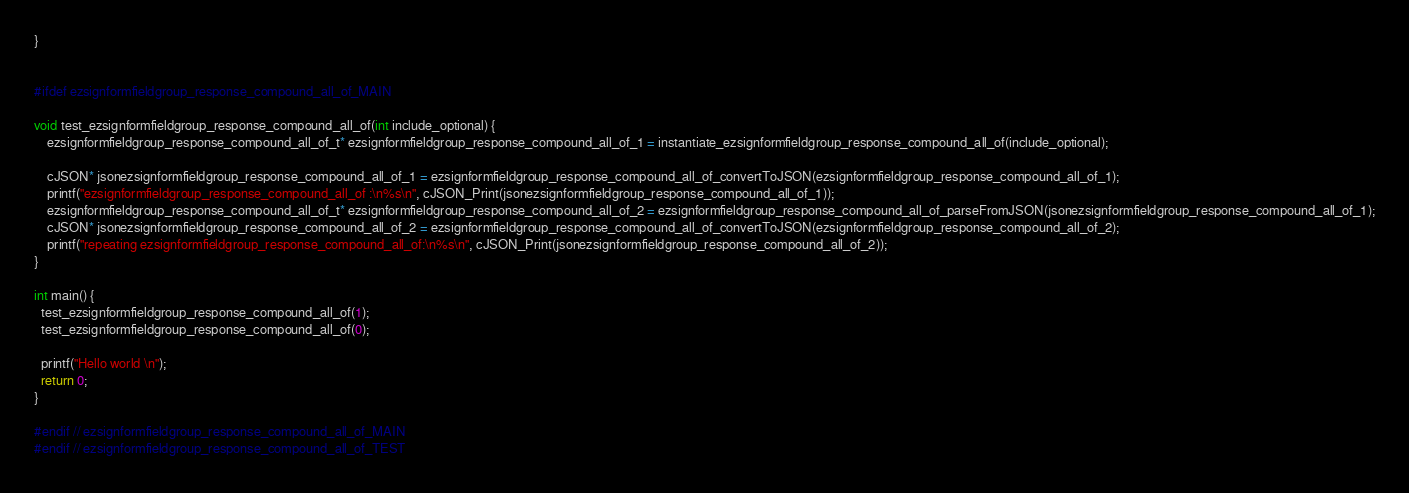Convert code to text. <code><loc_0><loc_0><loc_500><loc_500><_C_>}


#ifdef ezsignformfieldgroup_response_compound_all_of_MAIN

void test_ezsignformfieldgroup_response_compound_all_of(int include_optional) {
    ezsignformfieldgroup_response_compound_all_of_t* ezsignformfieldgroup_response_compound_all_of_1 = instantiate_ezsignformfieldgroup_response_compound_all_of(include_optional);

	cJSON* jsonezsignformfieldgroup_response_compound_all_of_1 = ezsignformfieldgroup_response_compound_all_of_convertToJSON(ezsignformfieldgroup_response_compound_all_of_1);
	printf("ezsignformfieldgroup_response_compound_all_of :\n%s\n", cJSON_Print(jsonezsignformfieldgroup_response_compound_all_of_1));
	ezsignformfieldgroup_response_compound_all_of_t* ezsignformfieldgroup_response_compound_all_of_2 = ezsignformfieldgroup_response_compound_all_of_parseFromJSON(jsonezsignformfieldgroup_response_compound_all_of_1);
	cJSON* jsonezsignformfieldgroup_response_compound_all_of_2 = ezsignformfieldgroup_response_compound_all_of_convertToJSON(ezsignformfieldgroup_response_compound_all_of_2);
	printf("repeating ezsignformfieldgroup_response_compound_all_of:\n%s\n", cJSON_Print(jsonezsignformfieldgroup_response_compound_all_of_2));
}

int main() {
  test_ezsignformfieldgroup_response_compound_all_of(1);
  test_ezsignformfieldgroup_response_compound_all_of(0);

  printf("Hello world \n");
  return 0;
}

#endif // ezsignformfieldgroup_response_compound_all_of_MAIN
#endif // ezsignformfieldgroup_response_compound_all_of_TEST
</code> 